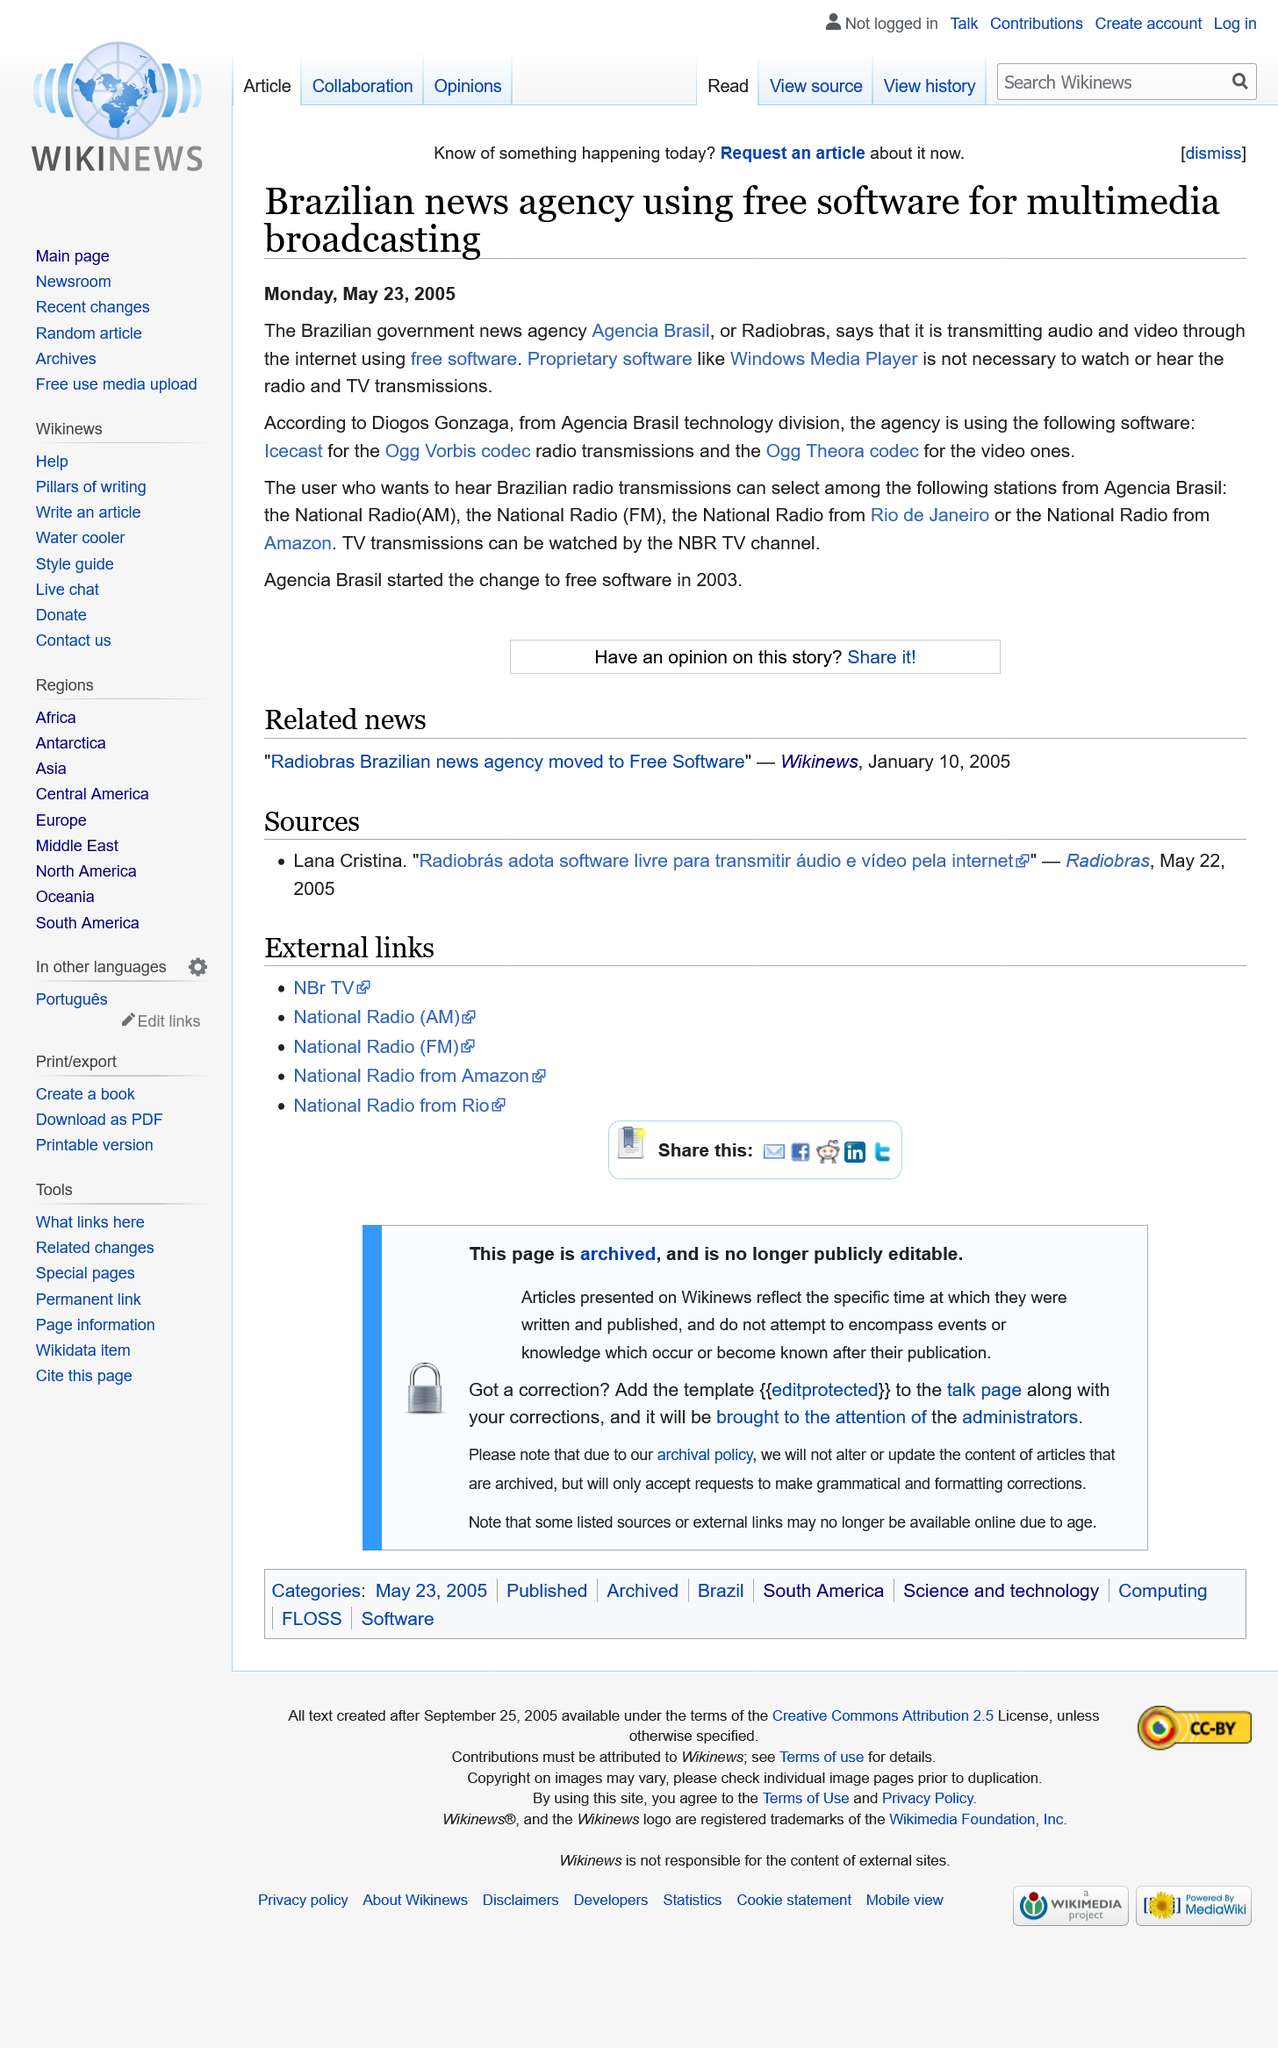Highlight a few significant elements in this photo. The software used for radio transmissions is Ogg Vorbis codec. The article about the Brazilian news agency using free software for multimedia broadcasting was published on May 23rd 2005. Agencia Brasil is transmitting audio and video on the internet using free software. 